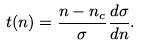<formula> <loc_0><loc_0><loc_500><loc_500>t ( n ) = \frac { n - n _ { c } } { \sigma } \frac { d \sigma } { d n } .</formula> 